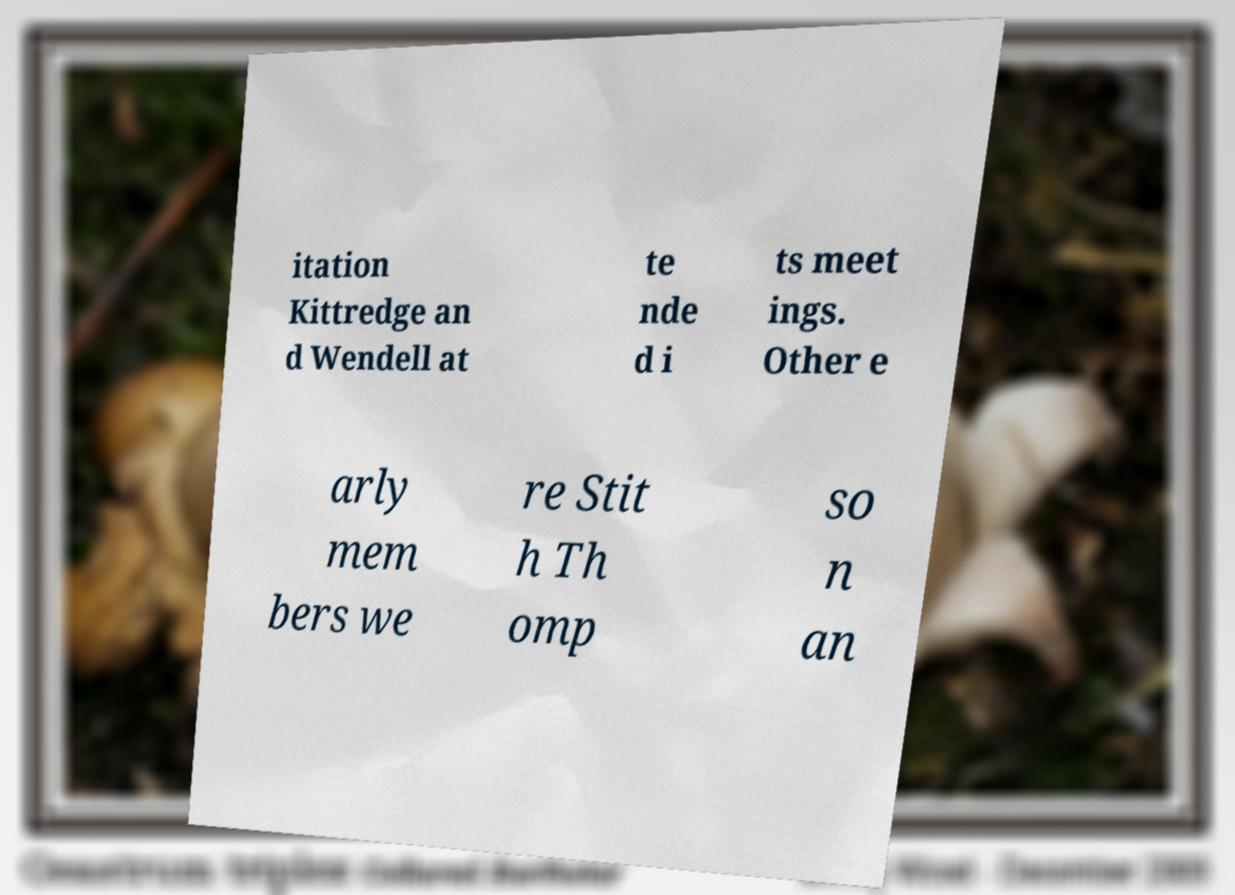Please read and relay the text visible in this image. What does it say? itation Kittredge an d Wendell at te nde d i ts meet ings. Other e arly mem bers we re Stit h Th omp so n an 